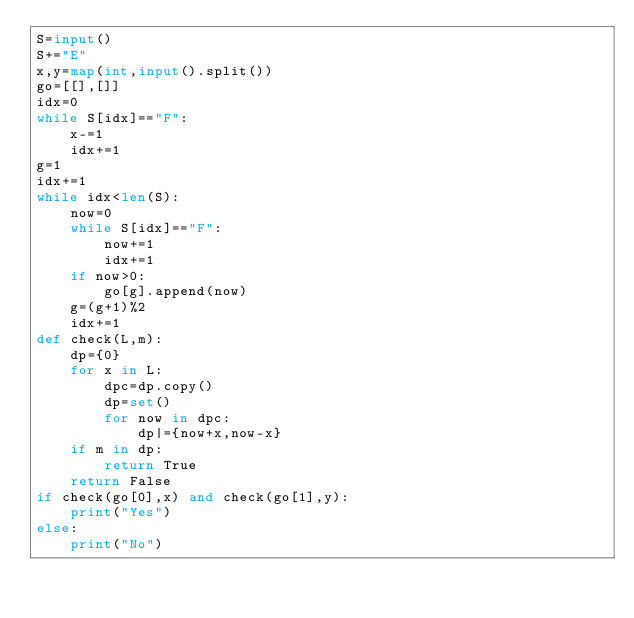Convert code to text. <code><loc_0><loc_0><loc_500><loc_500><_Python_>S=input()
S+="E"
x,y=map(int,input().split())
go=[[],[]]
idx=0
while S[idx]=="F":
    x-=1
    idx+=1
g=1
idx+=1
while idx<len(S):
    now=0
    while S[idx]=="F":
        now+=1
        idx+=1
    if now>0:
        go[g].append(now)
    g=(g+1)%2
    idx+=1
def check(L,m):
    dp={0}
    for x in L:
        dpc=dp.copy()
        dp=set()
        for now in dpc:
            dp|={now+x,now-x}
    if m in dp:
        return True
    return False
if check(go[0],x) and check(go[1],y):
    print("Yes")
else:
    print("No")</code> 